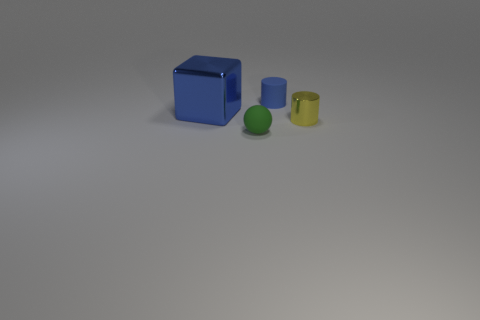There is a blue cylinder that is the same size as the green sphere; what is it made of?
Offer a very short reply. Rubber. What material is the blue object that is right of the tiny rubber thing to the left of the matte object that is behind the large blue object?
Provide a succinct answer. Rubber. What is the color of the metallic cube?
Your answer should be compact. Blue. What number of tiny things are yellow objects or green rubber spheres?
Your response must be concise. 2. What is the material of the tiny cylinder that is the same color as the big metal object?
Provide a short and direct response. Rubber. Do the small cylinder behind the yellow object and the thing that is left of the sphere have the same material?
Give a very brief answer. No. Is there a small blue matte thing?
Offer a very short reply. Yes. Are there more small yellow cylinders behind the blue cylinder than small yellow shiny cylinders that are behind the yellow thing?
Make the answer very short. No. There is another tiny thing that is the same shape as the small yellow object; what material is it?
Give a very brief answer. Rubber. Is there anything else that has the same size as the yellow thing?
Your answer should be compact. Yes. 